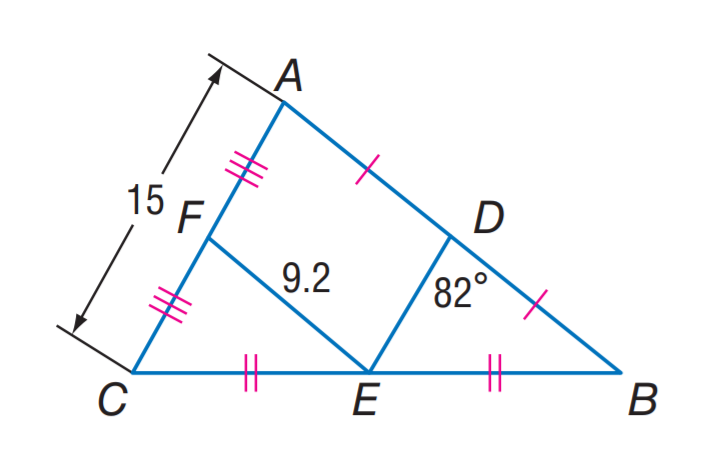Question: Find m \angle F E D.
Choices:
A. 8
B. 41
C. 49
D. 82
Answer with the letter. Answer: D Question: Find D E.
Choices:
A. 7.5
B. 9.2
C. 10
D. 18.4
Answer with the letter. Answer: A Question: Find D B.
Choices:
A. 7.5
B. 9.2
C. 15
D. 18.4
Answer with the letter. Answer: B 